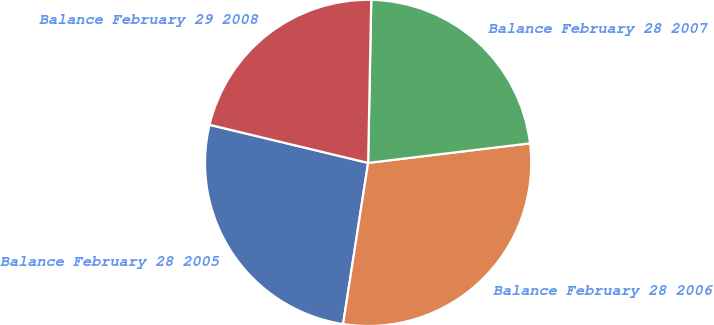Convert chart. <chart><loc_0><loc_0><loc_500><loc_500><pie_chart><fcel>Balance February 28 2005<fcel>Balance February 28 2006<fcel>Balance February 28 2007<fcel>Balance February 29 2008<nl><fcel>26.3%<fcel>29.37%<fcel>22.78%<fcel>21.55%<nl></chart> 